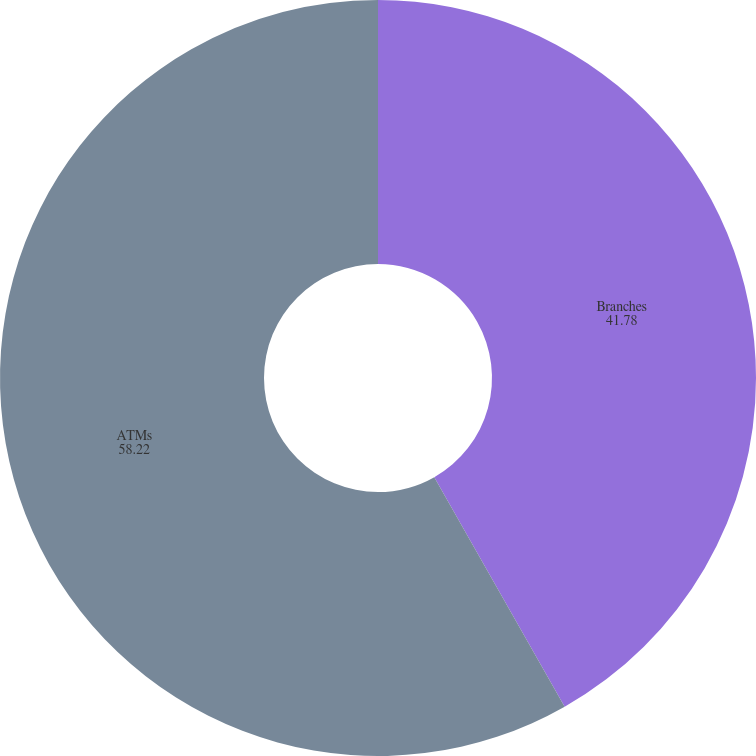Convert chart to OTSL. <chart><loc_0><loc_0><loc_500><loc_500><pie_chart><fcel>Branches<fcel>ATMs<nl><fcel>41.78%<fcel>58.22%<nl></chart> 